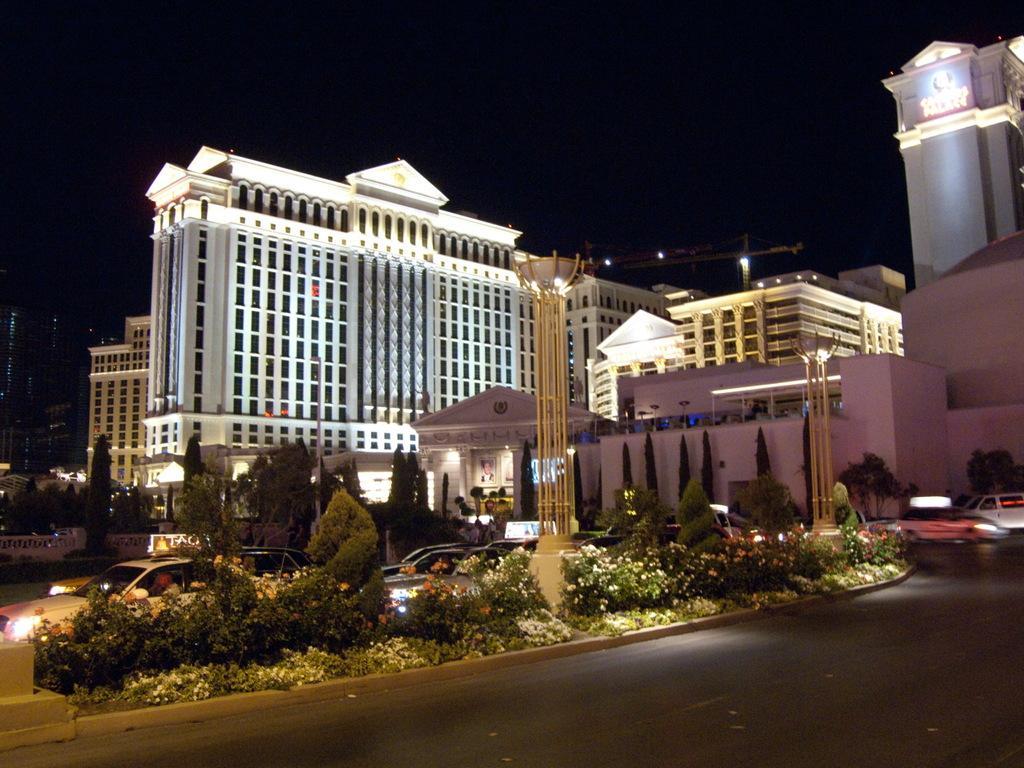In one or two sentences, can you explain what this image depicts? This is an image clicked in the dark. At the bottom of the image I can see the road. In the middle of the road there are some plants. At the back I can see many cars. In the background there are some buildings and poles. 